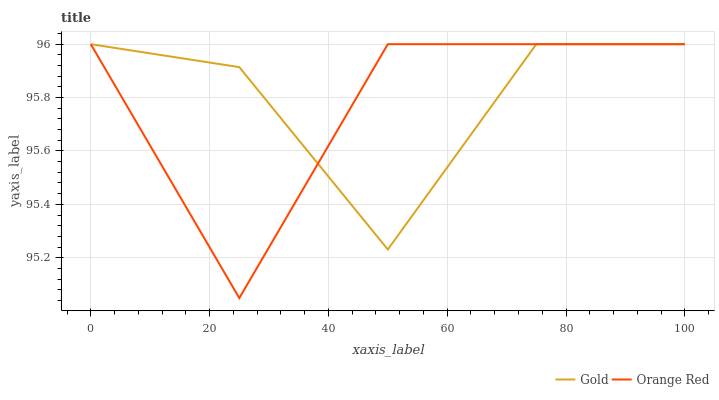Does Orange Red have the minimum area under the curve?
Answer yes or no. Yes. Does Gold have the maximum area under the curve?
Answer yes or no. Yes. Does Gold have the minimum area under the curve?
Answer yes or no. No. Is Gold the smoothest?
Answer yes or no. Yes. Is Orange Red the roughest?
Answer yes or no. Yes. Is Gold the roughest?
Answer yes or no. No. Does Orange Red have the lowest value?
Answer yes or no. Yes. Does Gold have the lowest value?
Answer yes or no. No. Does Gold have the highest value?
Answer yes or no. Yes. Does Orange Red intersect Gold?
Answer yes or no. Yes. Is Orange Red less than Gold?
Answer yes or no. No. Is Orange Red greater than Gold?
Answer yes or no. No. 